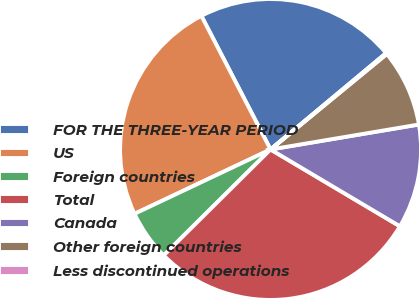Convert chart to OTSL. <chart><loc_0><loc_0><loc_500><loc_500><pie_chart><fcel>FOR THE THREE-YEAR PERIOD<fcel>US<fcel>Foreign countries<fcel>Total<fcel>Canada<fcel>Other foreign countries<fcel>Less discontinued operations<nl><fcel>21.54%<fcel>24.43%<fcel>5.4%<fcel>29.04%<fcel>11.18%<fcel>8.29%<fcel>0.12%<nl></chart> 